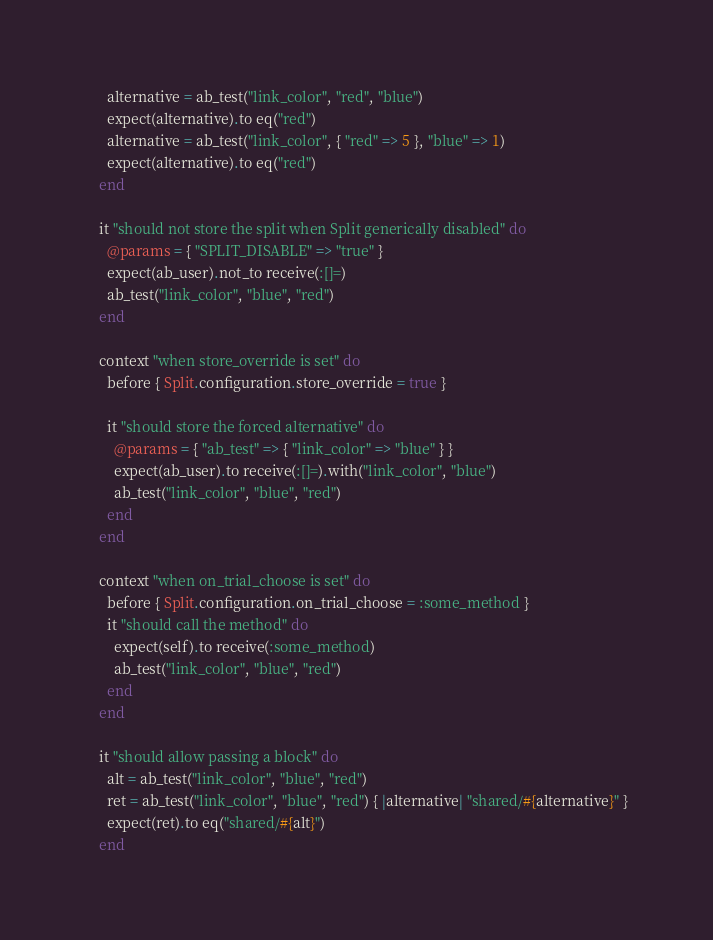Convert code to text. <code><loc_0><loc_0><loc_500><loc_500><_Ruby_>      alternative = ab_test("link_color", "red", "blue")
      expect(alternative).to eq("red")
      alternative = ab_test("link_color", { "red" => 5 }, "blue" => 1)
      expect(alternative).to eq("red")
    end

    it "should not store the split when Split generically disabled" do
      @params = { "SPLIT_DISABLE" => "true" }
      expect(ab_user).not_to receive(:[]=)
      ab_test("link_color", "blue", "red")
    end

    context "when store_override is set" do
      before { Split.configuration.store_override = true }

      it "should store the forced alternative" do
        @params = { "ab_test" => { "link_color" => "blue" } }
        expect(ab_user).to receive(:[]=).with("link_color", "blue")
        ab_test("link_color", "blue", "red")
      end
    end

    context "when on_trial_choose is set" do
      before { Split.configuration.on_trial_choose = :some_method }
      it "should call the method" do
        expect(self).to receive(:some_method)
        ab_test("link_color", "blue", "red")
      end
    end

    it "should allow passing a block" do
      alt = ab_test("link_color", "blue", "red")
      ret = ab_test("link_color", "blue", "red") { |alternative| "shared/#{alternative}" }
      expect(ret).to eq("shared/#{alt}")
    end
</code> 